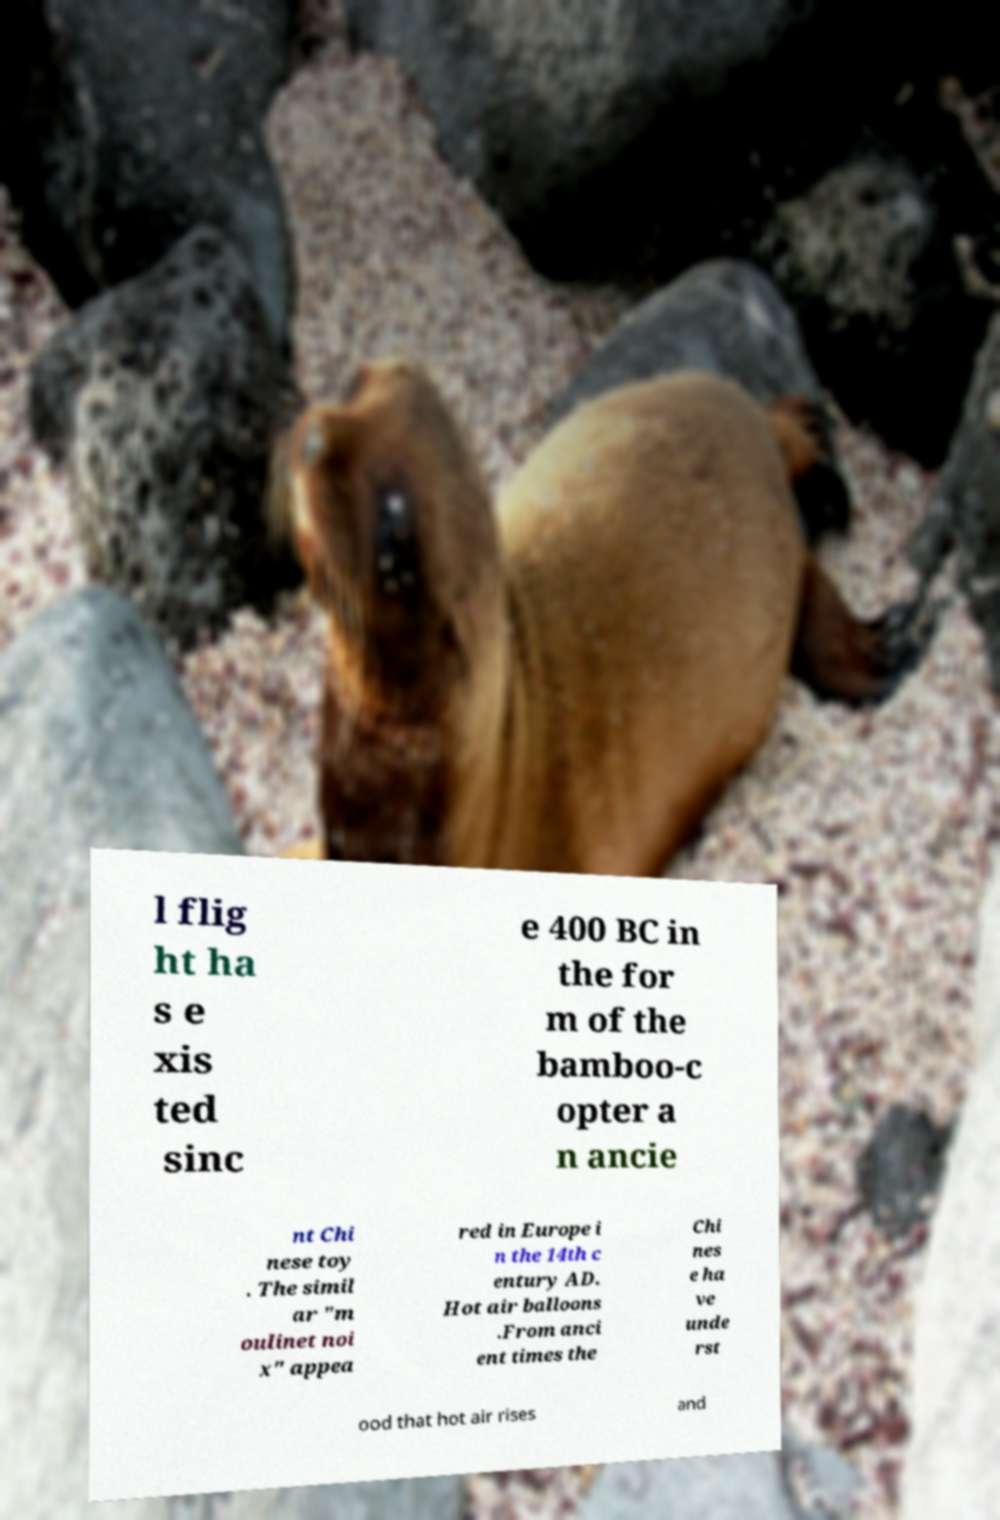For documentation purposes, I need the text within this image transcribed. Could you provide that? l flig ht ha s e xis ted sinc e 400 BC in the for m of the bamboo-c opter a n ancie nt Chi nese toy . The simil ar "m oulinet noi x" appea red in Europe i n the 14th c entury AD. Hot air balloons .From anci ent times the Chi nes e ha ve unde rst ood that hot air rises and 